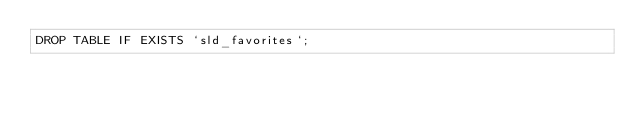<code> <loc_0><loc_0><loc_500><loc_500><_SQL_>DROP TABLE IF EXISTS `sld_favorites`;</code> 